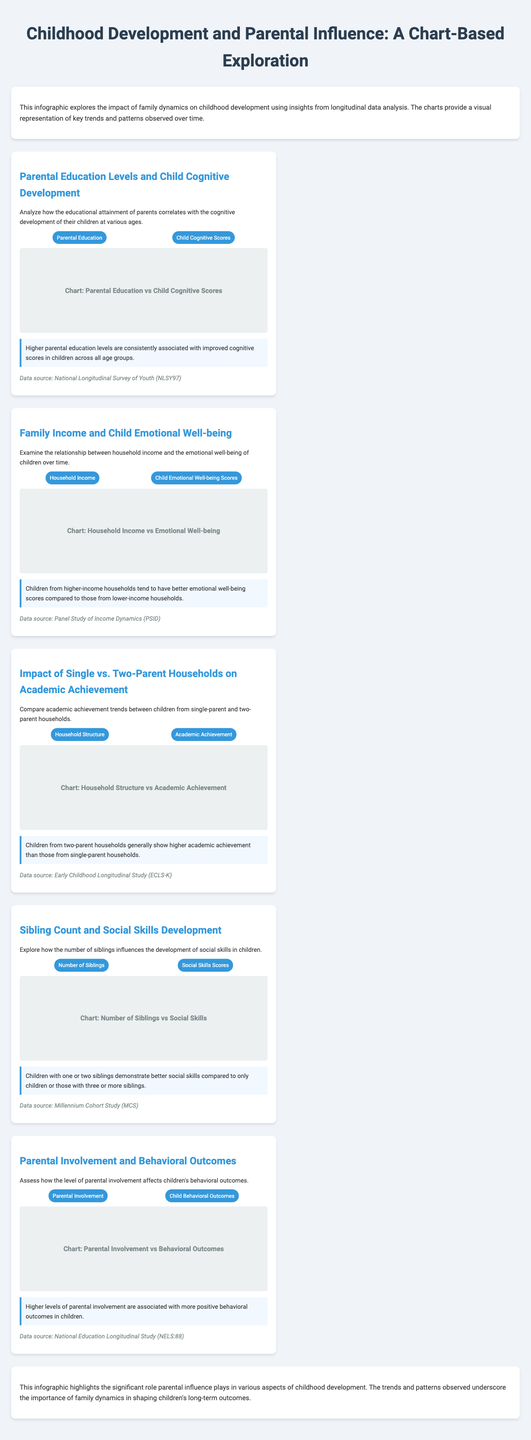what is the title of the infographic? The title, as presented at the top of the document, summarizes the main focus of the content.
Answer: Childhood Development and Parental Influence: A Chart-Based Exploration how many charts are included in the document? The document features multiple charts that present various aspects of childhood development and parental influence.
Answer: Five what data source is referenced for the chart on Parental Education Levels and Child Cognitive Development? Each chart provides a data source that supports the findings presented.
Answer: National Longitudinal Survey of Youth (NLSY97) which household structure shows higher academic achievement according to the infographic? The infographic presents findings contrasting different household structures regarding academic performance.
Answer: Two-parent households what trend is observed regarding household income and child emotional well-being? This question addresses the relationship observed through the visuals in the document.
Answer: Better emotional well-being scores what is the pattern regarding sibling count and social skills development? The infographic outlines specific patterns observed through analysis across the charts presented.
Answer: One or two siblings how does parental involvement affect children's behavioral outcomes? The document illustrates the impact of parental involvement directly related to behavioral outcomes.
Answer: More positive behavioral outcomes what is stated about parental education levels and child cognitive scores? This question explores the consistency of findings over different data points presented within the document.
Answer: Consistently associated with improved cognitive scores 